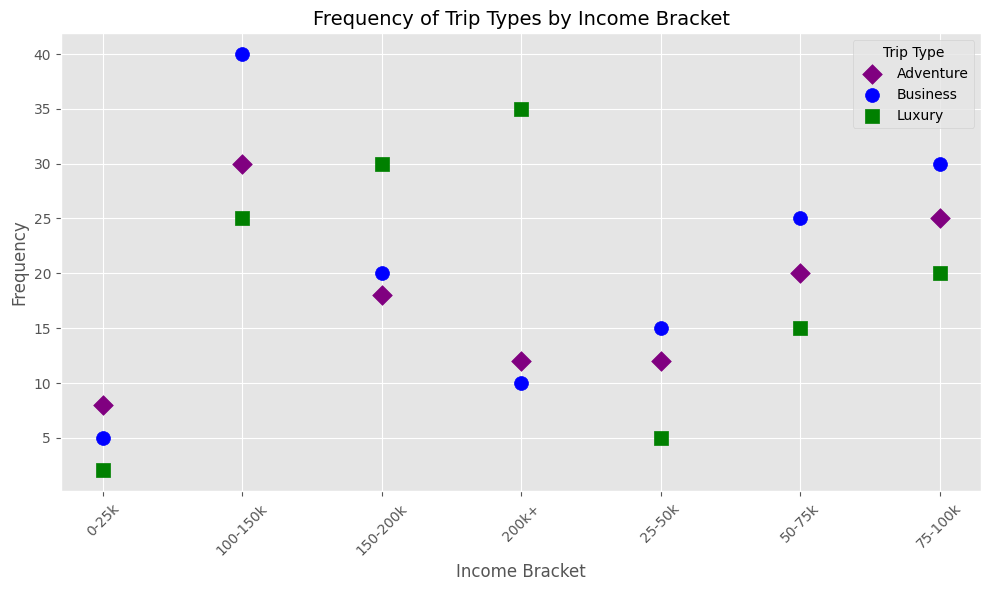What is the frequency of Adventure trips in the 0-25k income bracket? Identify the frequency point on the scatter plot where the income bracket is 0-25k and the trip type is Adventure.
Answer: 8 Which income bracket has the highest frequency of Luxury trips? Compare the heights of the points corresponding to Luxury trips across all income brackets on the scatter plot. The 200k+ bracket has the highest Luxury trips.
Answer: 200k+ How does the frequency of Business trips in the 0-25k bracket compare to the 50-75k bracket? Find the points for Business trips in both income brackets and compare their heights. The 50-75k bracket has a significantly higher frequency (25) than the 0-25k bracket (5).
Answer: 50-75k Which trip type has the highest frequency overall in the 75-100k income bracket? Among Business, Luxury, and Adventure trips in the 75-100k bracket, Business trips have the highest frequency based on the scatter plot.
Answer: Business Is the frequency of Adventure trips higher in the 100-150k or 150-200k income bracket? Compare the frequencies of Adventure trips between these two income brackets on the scatter plot. 100-150k has a higher frequency (30) than 150-200k (18).
Answer: 100-150k What is the average frequency of Luxury trips across all income brackets? Sum the frequencies of Luxury trips across all income brackets (2+5+15+20+25+30+35) and divide by the number of brackets (7). The total is 132, so the average is 132/7.
Answer: 18.86 How does the frequency of Business trips change with increasing income for each income bracket? Observe the trend of Business trips' frequencies across increasing income brackets. It generally increases from 5 (0-25k) to 40 (100-150k) and then decreases to 10 (200k+).
Answer: Generally increases, then decreases Which income bracket has the smallest difference in frequency between Adventure and Business trips? Calculate the absolute differences between Adventure and Business trips for each bracket: 0-25k(3), 25-50k(3), 50-75k(5), 75-100k(5), 100-150k(10), 150-200k(2), 200k+(2). The smallest differences are for 150-200k and 200k+ with a difference of 2.
Answer: 150-200k and 200k+ Among all the income brackets, which trip type shows the most variability in frequency? Assess the range of frequencies for each trip type across all income brackets. Business trips range from 5 to 40, Luxury from 2 to 35, Adventure from 8 to 30. Business trips show the most variability.
Answer: Business 